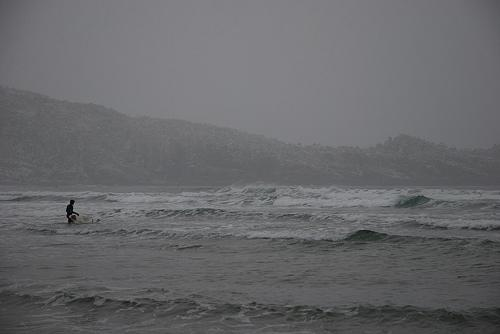What is the main activity happening in the scene involving a person? A person is wading in the water, holding a white surfboard and preparing to surf. Choose an object in the image and give a short description of it. There is a small white surfboard being held by a person in the water, likely preparing to surf some waves. Create a sentence suitable for a product advertisement based on the image. Experience the thrill of ocean waves with our lightweight white surfboard, designed for ultimate surfing adventures amid breathtaking natural scenery. What can you say about the water conditions in the scene? The ocean water is choppy with small waves, water foam, and cresting waves, making it suitable for surfing. In a few words, describe the view of the mountains in the image. The image showcases distant mountains covered with trees and plants, providing a picturesque backdrop. For the multi-choice VQA task, provide a question and a correct answer. Holding a white surfboard and preparing to surf. Can you provide a brief description of the landscape in the image? The image features a coastal scene with mountains in the distance, a bunch of forming waves, and trees growing by the ocean. What is the visual entailment task in this context? To determine if the image visually supports a textual description or claim about the scene. Explain the appearance of the sky in the picture. The sky during dusk appears with clouds, creating a serene and calming atmosphere. 